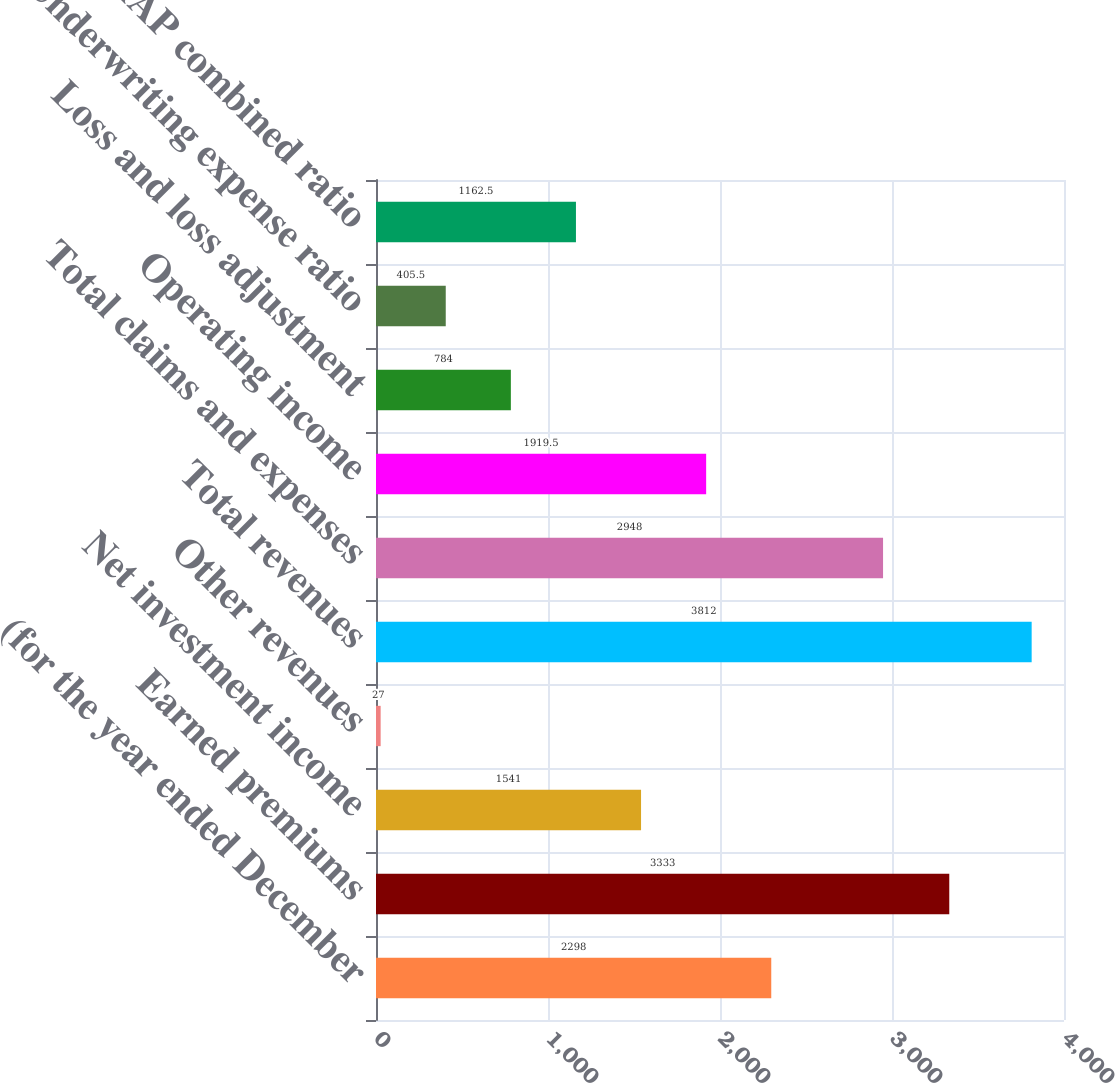<chart> <loc_0><loc_0><loc_500><loc_500><bar_chart><fcel>(for the year ended December<fcel>Earned premiums<fcel>Net investment income<fcel>Other revenues<fcel>Total revenues<fcel>Total claims and expenses<fcel>Operating income<fcel>Loss and loss adjustment<fcel>Underwriting expense ratio<fcel>GAAP combined ratio<nl><fcel>2298<fcel>3333<fcel>1541<fcel>27<fcel>3812<fcel>2948<fcel>1919.5<fcel>784<fcel>405.5<fcel>1162.5<nl></chart> 